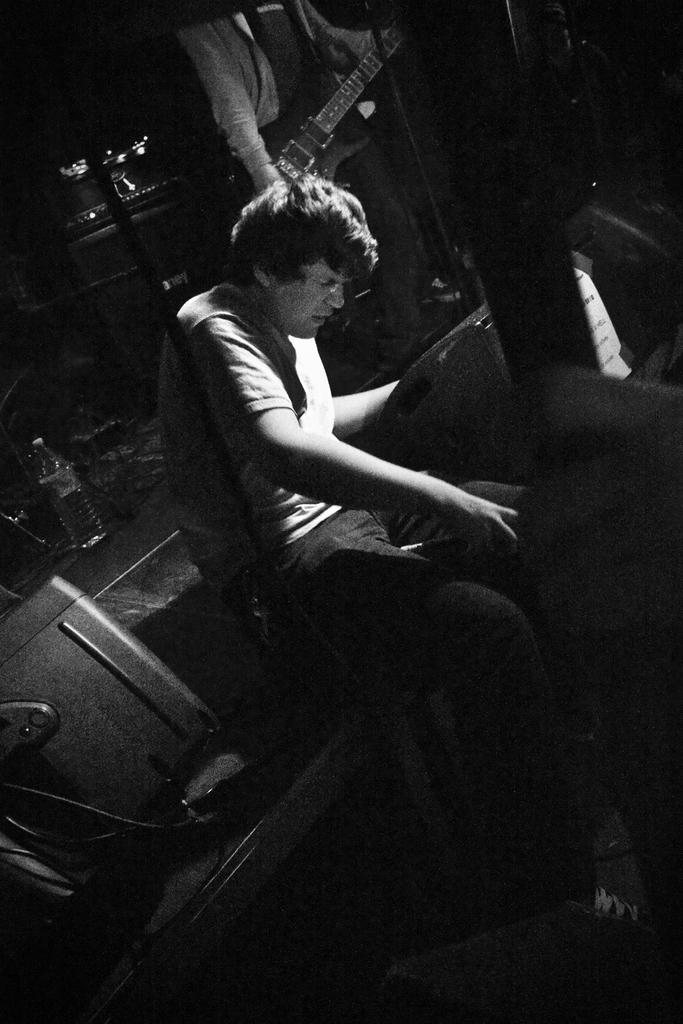How many people are in the image? There are two people in the image. What is one of the people holding in the image? One of the people is holding a guitar. How many trucks are visible in the image? There are no trucks visible in the image. What type of sheep can be seen in the image? There are no sheep present in the image. What type of print is visible on the guitar in the image? There is no print visible on the guitar in the image. 